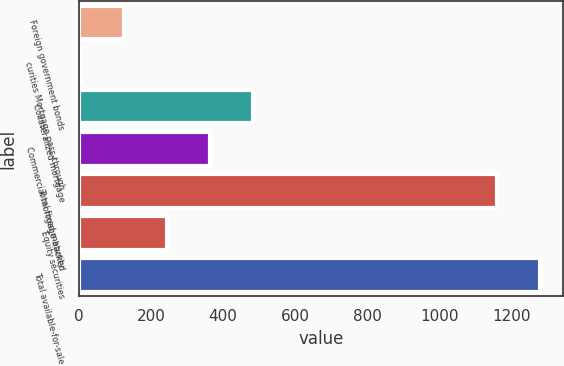Convert chart to OTSL. <chart><loc_0><loc_0><loc_500><loc_500><bar_chart><fcel>Foreign government bonds<fcel>curities Mortgage pass-through<fcel>Collateralized mortgage<fcel>Commercial mortgage-backed<fcel>Total fixed maturity<fcel>Equity securities<fcel>Total available-for-sale<nl><fcel>124.7<fcel>5<fcel>483.8<fcel>364.1<fcel>1159<fcel>244.4<fcel>1278.7<nl></chart> 